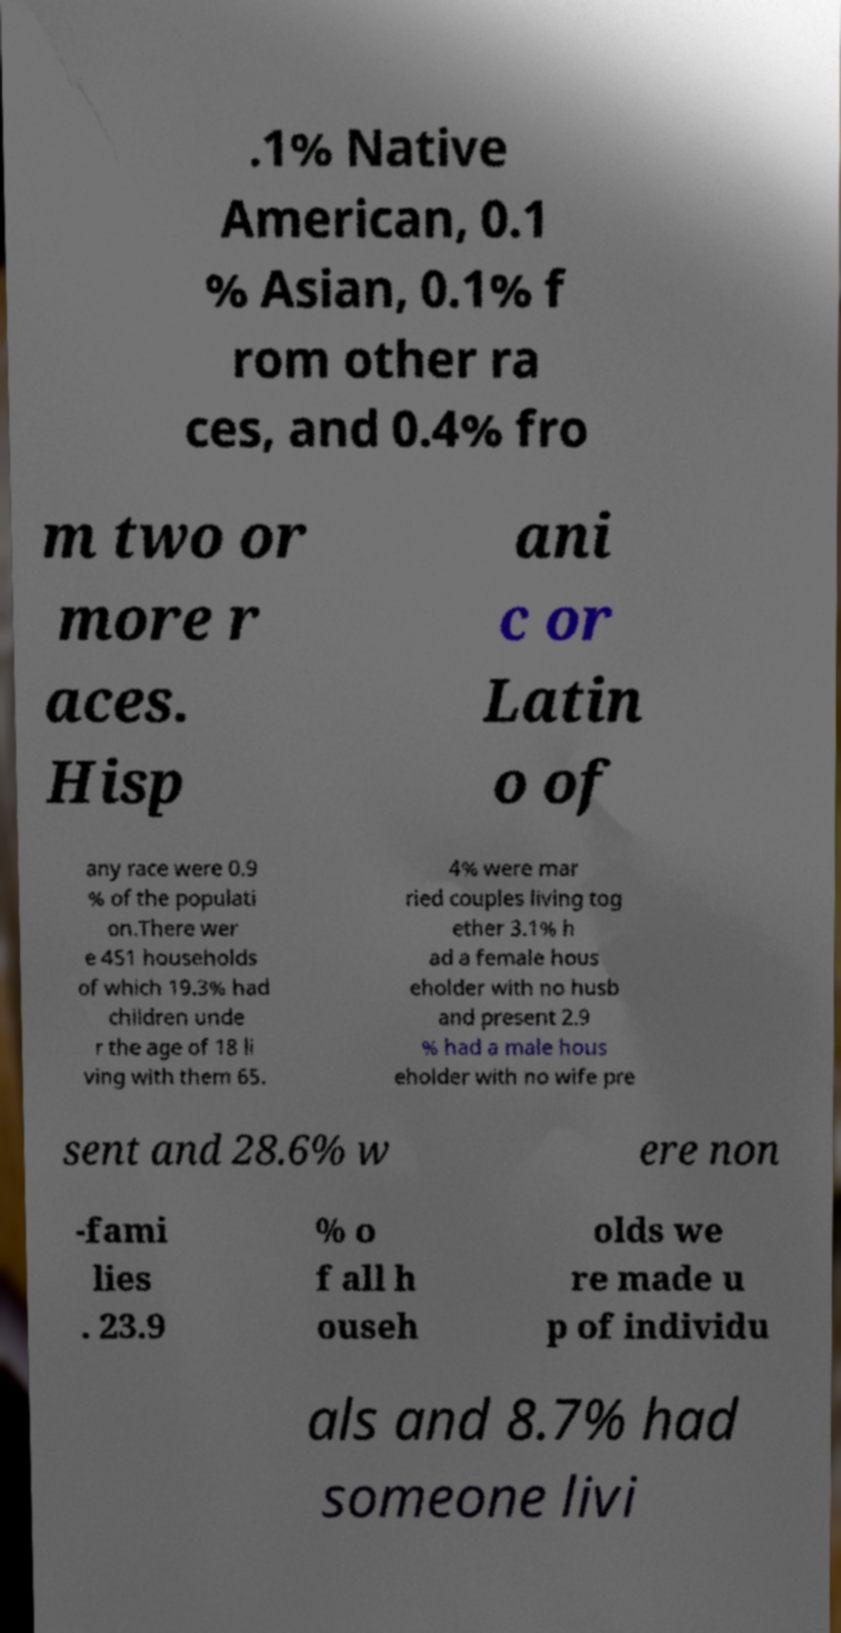There's text embedded in this image that I need extracted. Can you transcribe it verbatim? .1% Native American, 0.1 % Asian, 0.1% f rom other ra ces, and 0.4% fro m two or more r aces. Hisp ani c or Latin o of any race were 0.9 % of the populati on.There wer e 451 households of which 19.3% had children unde r the age of 18 li ving with them 65. 4% were mar ried couples living tog ether 3.1% h ad a female hous eholder with no husb and present 2.9 % had a male hous eholder with no wife pre sent and 28.6% w ere non -fami lies . 23.9 % o f all h ouseh olds we re made u p of individu als and 8.7% had someone livi 